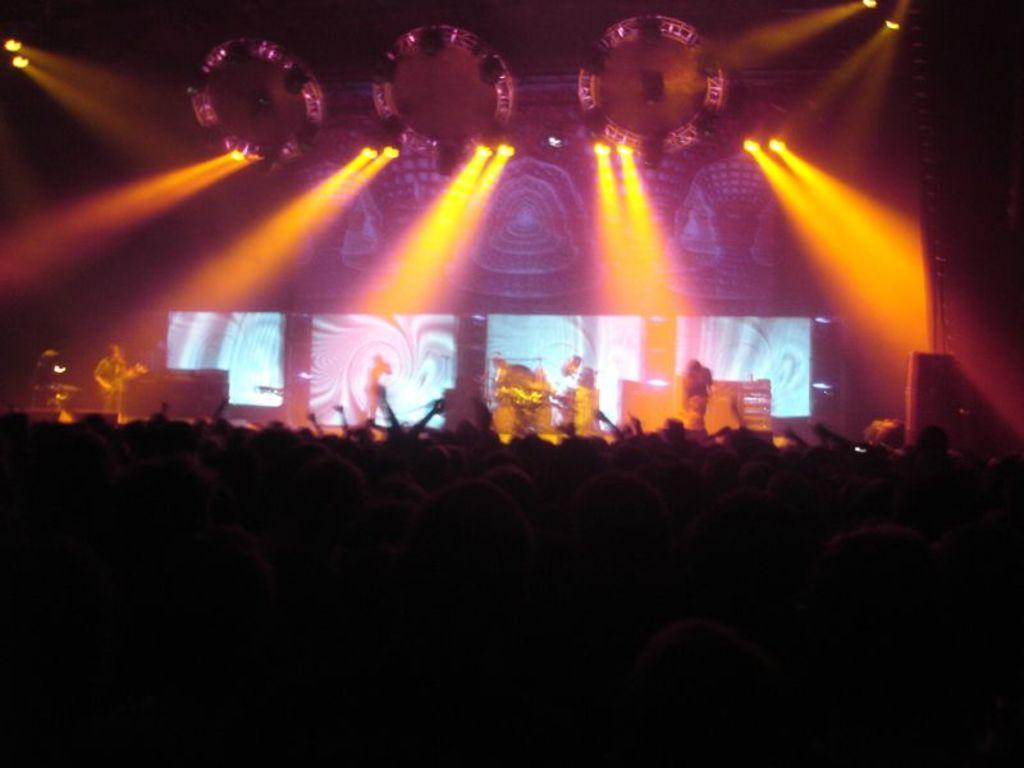What is happening on the stage in the image? There are people on the stage in the image. What type of lighting is visible in the image? DJ lights are visible in the image. What else can be seen in the image besides the people on stage and the lights? Musical instruments are present in the image. What type of jar is being used by the servant in the image? There is no jar or servant present in the image. What kind of curve can be seen in the image? There is no curve visible in the image; it features people on stage, DJ lights, and musical instruments. 